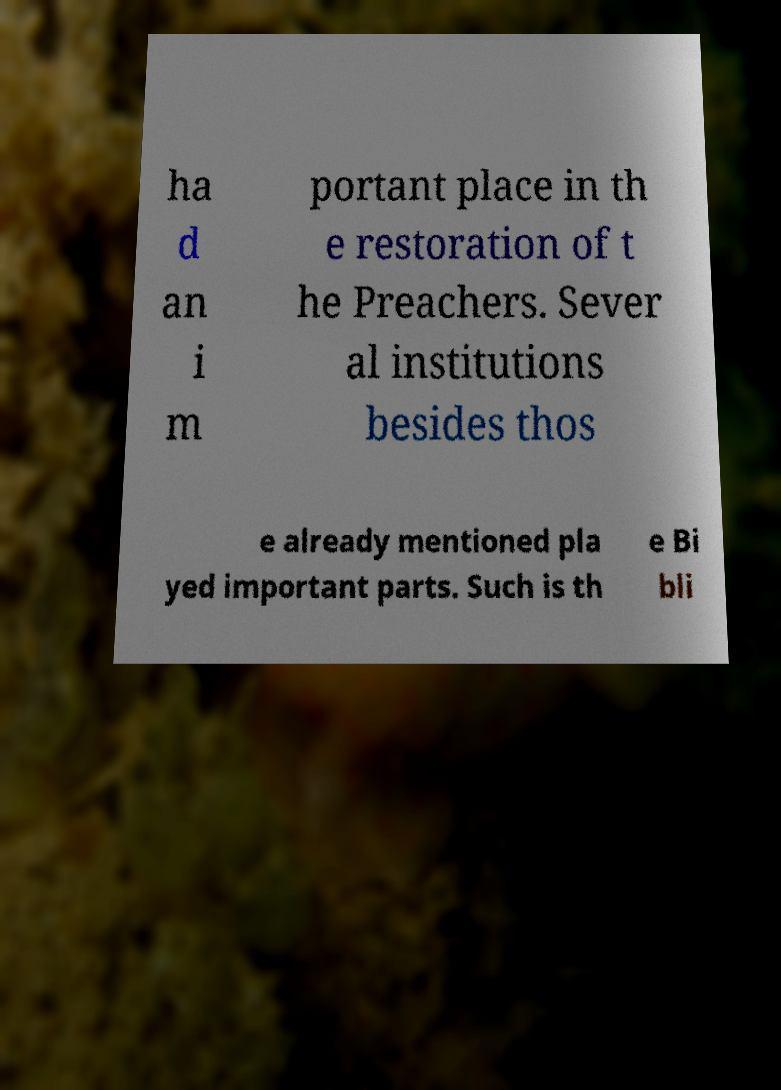Please identify and transcribe the text found in this image. ha d an i m portant place in th e restoration of t he Preachers. Sever al institutions besides thos e already mentioned pla yed important parts. Such is th e Bi bli 